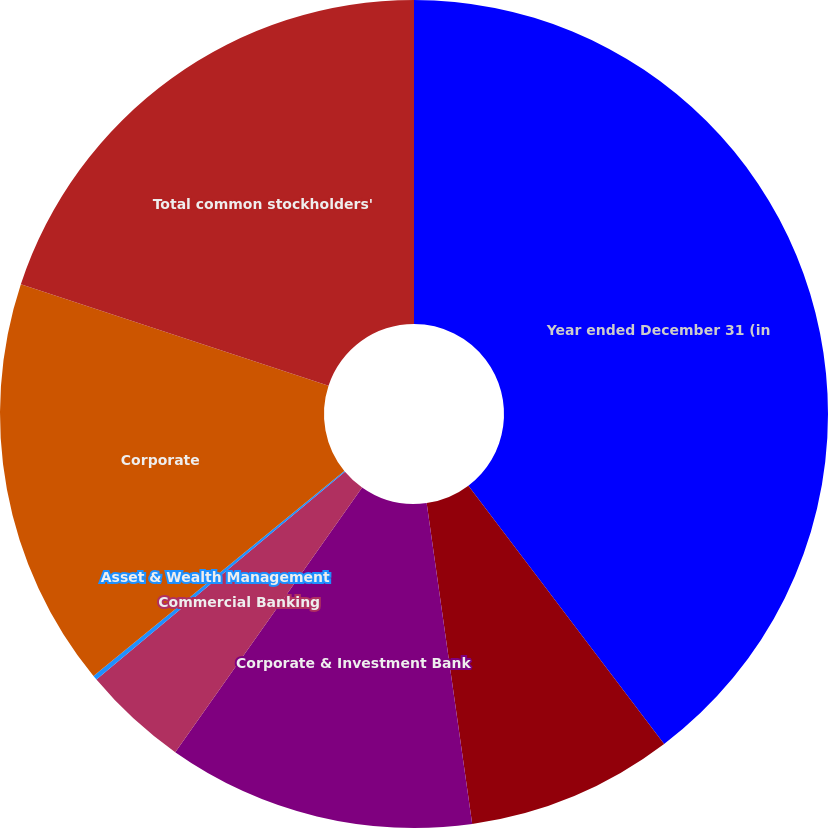Convert chart. <chart><loc_0><loc_0><loc_500><loc_500><pie_chart><fcel>Year ended December 31 (in<fcel>Consumer & Community Banking<fcel>Corporate & Investment Bank<fcel>Commercial Banking<fcel>Asset & Wealth Management<fcel>Corporate<fcel>Total common stockholders'<nl><fcel>39.68%<fcel>8.08%<fcel>12.03%<fcel>4.13%<fcel>0.18%<fcel>15.98%<fcel>19.93%<nl></chart> 